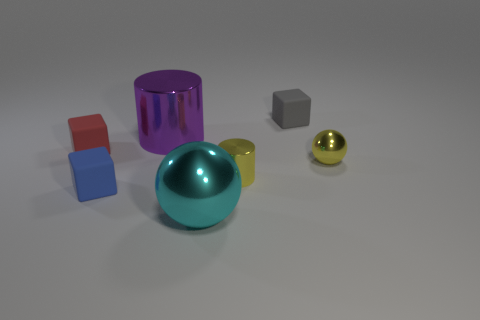What shape is the metallic object that is the same color as the tiny metallic cylinder?
Provide a short and direct response. Sphere. How many cylinders are green matte things or tiny red matte objects?
Make the answer very short. 0. Is the size of the gray rubber object the same as the shiny cylinder on the right side of the purple shiny cylinder?
Make the answer very short. Yes. Is the number of large objects that are in front of the blue block greater than the number of large blue blocks?
Ensure brevity in your answer.  Yes. There is a yellow cylinder that is the same material as the yellow sphere; what size is it?
Provide a short and direct response. Small. Are there any small spheres that have the same color as the big shiny sphere?
Your answer should be compact. No. What number of things are matte things or tiny objects that are to the left of the yellow shiny ball?
Make the answer very short. 4. Is the number of purple metal things greater than the number of purple rubber spheres?
Offer a terse response. Yes. The shiny object that is the same color as the tiny metallic sphere is what size?
Provide a short and direct response. Small. Are there any blue cubes made of the same material as the tiny red cube?
Offer a terse response. Yes. 